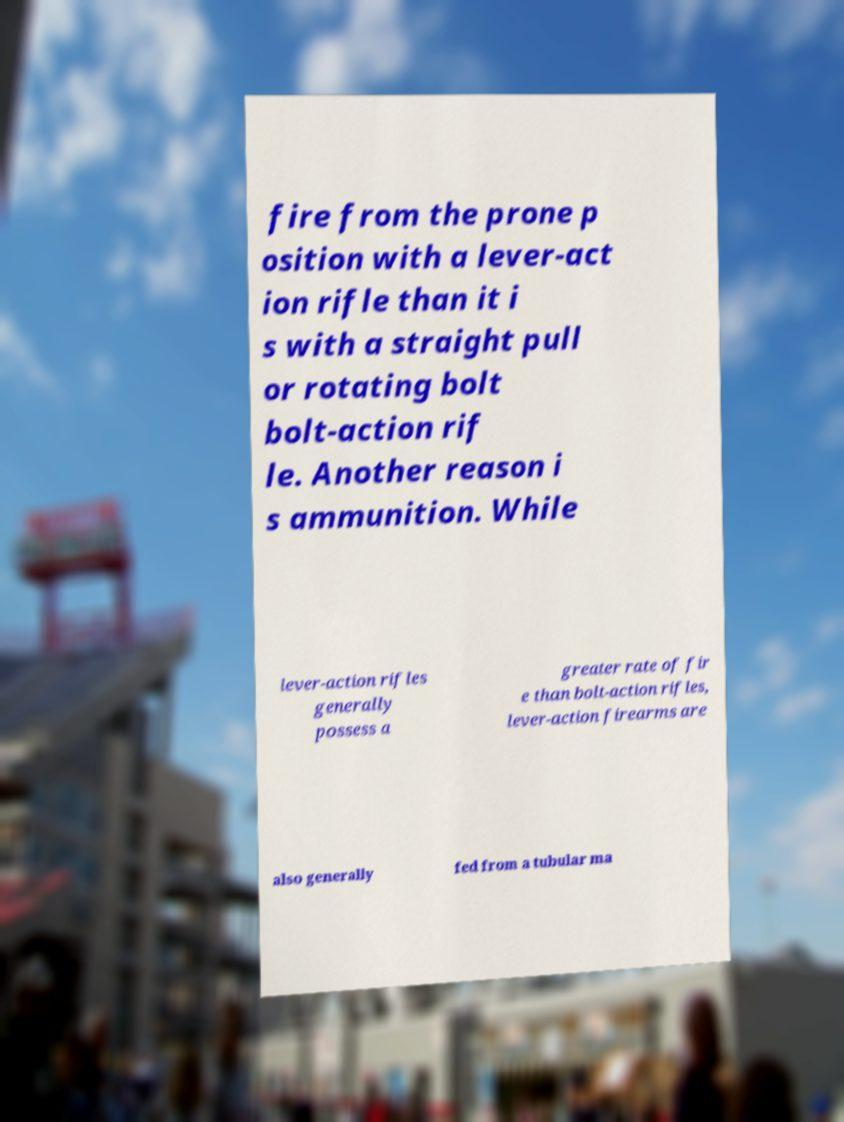What messages or text are displayed in this image? I need them in a readable, typed format. fire from the prone p osition with a lever-act ion rifle than it i s with a straight pull or rotating bolt bolt-action rif le. Another reason i s ammunition. While lever-action rifles generally possess a greater rate of fir e than bolt-action rifles, lever-action firearms are also generally fed from a tubular ma 